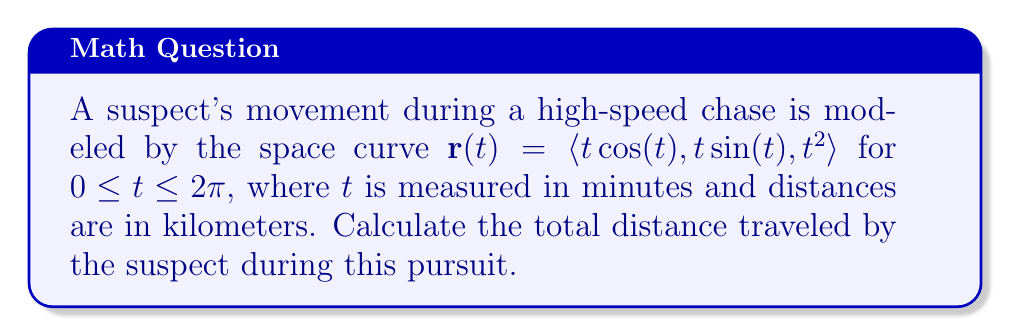Could you help me with this problem? To find the total distance traveled by the suspect, we need to calculate the arc length of the given space curve. The formula for arc length is:

$$s = \int_a^b \sqrt{\left(\frac{dx}{dt}\right)^2 + \left(\frac{dy}{dt}\right)^2 + \left(\frac{dz}{dt}\right)^2} dt$$

Let's follow these steps:

1) First, we need to find $\frac{dx}{dt}$, $\frac{dy}{dt}$, and $\frac{dz}{dt}$:

   $\frac{dx}{dt} = \cos(t) - t\sin(t)$
   $\frac{dy}{dt} = \sin(t) + t\cos(t)$
   $\frac{dz}{dt} = 2t$

2) Now, let's substitute these into the arc length formula:

   $$s = \int_0^{2\pi} \sqrt{(\cos(t) - t\sin(t))^2 + (\sin(t) + t\cos(t))^2 + (2t)^2} dt$$

3) Simplify the expression under the square root:

   $$\begin{align*}
   &(\cos(t) - t\sin(t))^2 + (\sin(t) + t\cos(t))^2 + (2t)^2 \\
   &= \cos^2(t) - 2t\cos(t)\sin(t) + t^2\sin^2(t) + \sin^2(t) + 2t\sin(t)\cos(t) + t^2\cos^2(t) + 4t^2 \\
   &= \cos^2(t) + \sin^2(t) + t^2\sin^2(t) + t^2\cos^2(t) + 4t^2 \\
   &= 1 + t^2 + 4t^2 \\
   &= 1 + 5t^2
   \end{align*}$$

4) Our integral now becomes:

   $$s = \int_0^{2\pi} \sqrt{1 + 5t^2} dt$$

5) This integral doesn't have an elementary antiderivative. We need to use numerical integration methods to evaluate it. Using a computer algebra system or numerical integration tool, we find:

   $$s \approx 22.6208 \text{ km}$$

Thus, the suspect traveled approximately 22.6208 kilometers during the chase.
Answer: The total distance traveled by the suspect is approximately 22.6208 kilometers. 